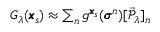<formula> <loc_0><loc_0><loc_500><loc_500>\begin{array} { r } { G _ { \lambda } ( \pm b { x } _ { s } ) \approx \sum _ { n } g ^ { \pm b { x } _ { s } } ( \pm b { \sigma } ^ { n } ) [ \vec { \mathcal { P } } _ { \lambda } ] _ { n } } \end{array}</formula> 